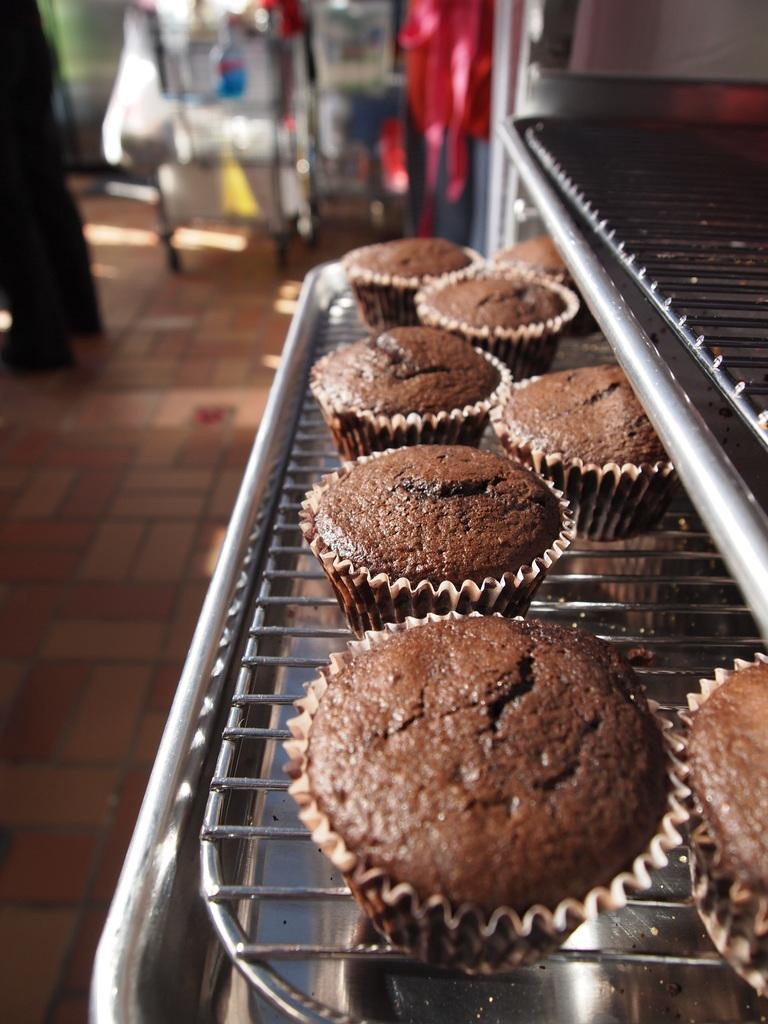What type of dessert can be seen in the image? There are cupcakes in the image. How are the cupcakes arranged or displayed? The cupcakes are in a rack. Can you describe the presence of a person in the image? There is a person standing in the image. What can be said about the background of the image? The background of the image is blurred. What is the plot of the story unfolding in the image? There is no story or plot depicted in the image; it simply shows cupcakes in a rack with a person standing nearby. 